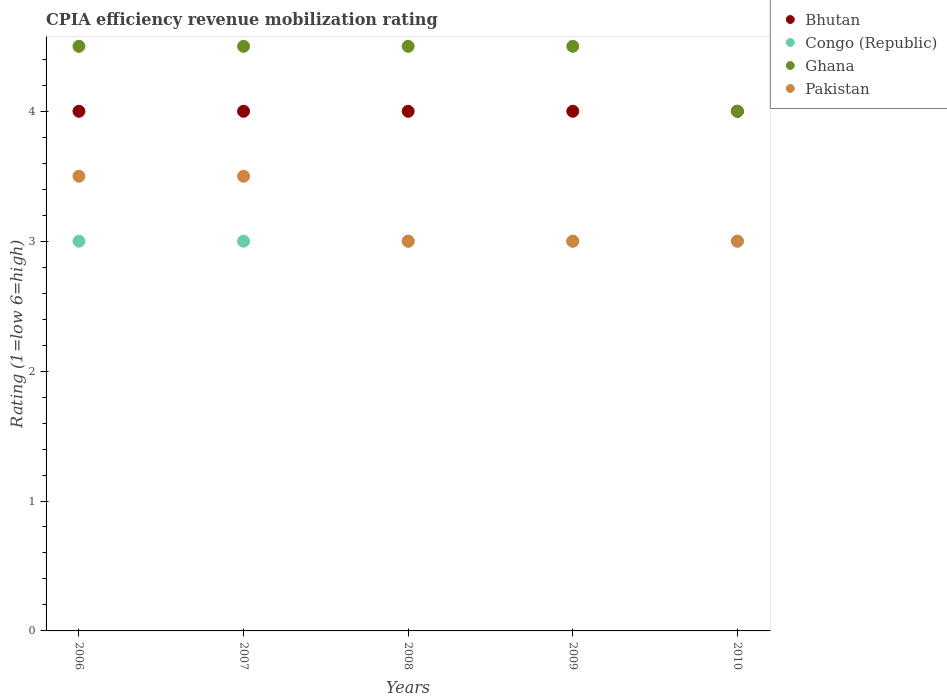Is the number of dotlines equal to the number of legend labels?
Keep it short and to the point. Yes. What is the CPIA rating in Ghana in 2008?
Offer a terse response. 4.5. Across all years, what is the maximum CPIA rating in Congo (Republic)?
Give a very brief answer. 3. Across all years, what is the minimum CPIA rating in Bhutan?
Provide a short and direct response. 4. In which year was the CPIA rating in Pakistan maximum?
Your answer should be compact. 2006. In which year was the CPIA rating in Ghana minimum?
Make the answer very short. 2010. What is the total CPIA rating in Bhutan in the graph?
Make the answer very short. 20. What is the difference between the CPIA rating in Pakistan in 2006 and that in 2008?
Your answer should be compact. 0.5. What is the difference between the CPIA rating in Congo (Republic) in 2006 and the CPIA rating in Bhutan in 2007?
Offer a terse response. -1. In the year 2007, what is the difference between the CPIA rating in Pakistan and CPIA rating in Ghana?
Offer a terse response. -1. What is the ratio of the CPIA rating in Congo (Republic) in 2006 to that in 2009?
Your response must be concise. 1. Is the CPIA rating in Congo (Republic) in 2006 less than that in 2009?
Your response must be concise. No. What is the difference between the highest and the second highest CPIA rating in Pakistan?
Your answer should be compact. 0. In how many years, is the CPIA rating in Pakistan greater than the average CPIA rating in Pakistan taken over all years?
Your response must be concise. 2. Is the sum of the CPIA rating in Congo (Republic) in 2006 and 2009 greater than the maximum CPIA rating in Bhutan across all years?
Keep it short and to the point. Yes. How many dotlines are there?
Offer a terse response. 4. What is the difference between two consecutive major ticks on the Y-axis?
Make the answer very short. 1. Are the values on the major ticks of Y-axis written in scientific E-notation?
Keep it short and to the point. No. Does the graph contain any zero values?
Your answer should be compact. No. What is the title of the graph?
Provide a succinct answer. CPIA efficiency revenue mobilization rating. What is the label or title of the Y-axis?
Keep it short and to the point. Rating (1=low 6=high). What is the Rating (1=low 6=high) in Congo (Republic) in 2006?
Offer a terse response. 3. What is the Rating (1=low 6=high) of Ghana in 2006?
Offer a very short reply. 4.5. What is the Rating (1=low 6=high) of Congo (Republic) in 2007?
Offer a very short reply. 3. What is the Rating (1=low 6=high) of Pakistan in 2007?
Provide a short and direct response. 3.5. What is the Rating (1=low 6=high) of Bhutan in 2008?
Keep it short and to the point. 4. What is the Rating (1=low 6=high) in Bhutan in 2009?
Provide a short and direct response. 4. What is the Rating (1=low 6=high) in Congo (Republic) in 2010?
Provide a short and direct response. 3. Across all years, what is the maximum Rating (1=low 6=high) in Ghana?
Your answer should be very brief. 4.5. Across all years, what is the minimum Rating (1=low 6=high) of Congo (Republic)?
Your response must be concise. 3. What is the total Rating (1=low 6=high) in Bhutan in the graph?
Your response must be concise. 20. What is the total Rating (1=low 6=high) in Congo (Republic) in the graph?
Keep it short and to the point. 15. What is the total Rating (1=low 6=high) of Pakistan in the graph?
Provide a succinct answer. 16. What is the difference between the Rating (1=low 6=high) in Bhutan in 2006 and that in 2007?
Make the answer very short. 0. What is the difference between the Rating (1=low 6=high) of Congo (Republic) in 2006 and that in 2007?
Your answer should be compact. 0. What is the difference between the Rating (1=low 6=high) of Bhutan in 2006 and that in 2008?
Offer a terse response. 0. What is the difference between the Rating (1=low 6=high) of Pakistan in 2006 and that in 2008?
Give a very brief answer. 0.5. What is the difference between the Rating (1=low 6=high) of Congo (Republic) in 2006 and that in 2009?
Offer a very short reply. 0. What is the difference between the Rating (1=low 6=high) of Ghana in 2006 and that in 2009?
Your answer should be very brief. 0. What is the difference between the Rating (1=low 6=high) in Pakistan in 2006 and that in 2009?
Your response must be concise. 0.5. What is the difference between the Rating (1=low 6=high) in Ghana in 2006 and that in 2010?
Offer a terse response. 0.5. What is the difference between the Rating (1=low 6=high) of Pakistan in 2006 and that in 2010?
Your answer should be very brief. 0.5. What is the difference between the Rating (1=low 6=high) of Congo (Republic) in 2007 and that in 2008?
Keep it short and to the point. 0. What is the difference between the Rating (1=low 6=high) in Pakistan in 2007 and that in 2008?
Make the answer very short. 0.5. What is the difference between the Rating (1=low 6=high) in Congo (Republic) in 2007 and that in 2009?
Your response must be concise. 0. What is the difference between the Rating (1=low 6=high) of Congo (Republic) in 2007 and that in 2010?
Your response must be concise. 0. What is the difference between the Rating (1=low 6=high) in Pakistan in 2008 and that in 2009?
Offer a terse response. 0. What is the difference between the Rating (1=low 6=high) in Bhutan in 2008 and that in 2010?
Offer a terse response. 0. What is the difference between the Rating (1=low 6=high) of Congo (Republic) in 2008 and that in 2010?
Offer a very short reply. 0. What is the difference between the Rating (1=low 6=high) of Ghana in 2008 and that in 2010?
Provide a succinct answer. 0.5. What is the difference between the Rating (1=low 6=high) of Pakistan in 2008 and that in 2010?
Make the answer very short. 0. What is the difference between the Rating (1=low 6=high) in Bhutan in 2009 and that in 2010?
Your response must be concise. 0. What is the difference between the Rating (1=low 6=high) of Pakistan in 2009 and that in 2010?
Ensure brevity in your answer.  0. What is the difference between the Rating (1=low 6=high) of Bhutan in 2006 and the Rating (1=low 6=high) of Congo (Republic) in 2007?
Your answer should be very brief. 1. What is the difference between the Rating (1=low 6=high) in Bhutan in 2006 and the Rating (1=low 6=high) in Ghana in 2007?
Make the answer very short. -0.5. What is the difference between the Rating (1=low 6=high) of Congo (Republic) in 2006 and the Rating (1=low 6=high) of Ghana in 2007?
Provide a short and direct response. -1.5. What is the difference between the Rating (1=low 6=high) of Ghana in 2006 and the Rating (1=low 6=high) of Pakistan in 2007?
Your answer should be very brief. 1. What is the difference between the Rating (1=low 6=high) of Bhutan in 2006 and the Rating (1=low 6=high) of Pakistan in 2008?
Keep it short and to the point. 1. What is the difference between the Rating (1=low 6=high) in Congo (Republic) in 2006 and the Rating (1=low 6=high) in Pakistan in 2008?
Keep it short and to the point. 0. What is the difference between the Rating (1=low 6=high) of Ghana in 2006 and the Rating (1=low 6=high) of Pakistan in 2008?
Your response must be concise. 1.5. What is the difference between the Rating (1=low 6=high) of Bhutan in 2006 and the Rating (1=low 6=high) of Congo (Republic) in 2009?
Provide a succinct answer. 1. What is the difference between the Rating (1=low 6=high) in Bhutan in 2006 and the Rating (1=low 6=high) in Ghana in 2009?
Provide a short and direct response. -0.5. What is the difference between the Rating (1=low 6=high) of Ghana in 2006 and the Rating (1=low 6=high) of Pakistan in 2009?
Make the answer very short. 1.5. What is the difference between the Rating (1=low 6=high) of Bhutan in 2006 and the Rating (1=low 6=high) of Ghana in 2010?
Your answer should be compact. 0. What is the difference between the Rating (1=low 6=high) of Congo (Republic) in 2006 and the Rating (1=low 6=high) of Ghana in 2010?
Offer a terse response. -1. What is the difference between the Rating (1=low 6=high) in Ghana in 2006 and the Rating (1=low 6=high) in Pakistan in 2010?
Ensure brevity in your answer.  1.5. What is the difference between the Rating (1=low 6=high) in Congo (Republic) in 2007 and the Rating (1=low 6=high) in Pakistan in 2008?
Offer a very short reply. 0. What is the difference between the Rating (1=low 6=high) in Ghana in 2007 and the Rating (1=low 6=high) in Pakistan in 2008?
Offer a very short reply. 1.5. What is the difference between the Rating (1=low 6=high) of Bhutan in 2007 and the Rating (1=low 6=high) of Congo (Republic) in 2009?
Your response must be concise. 1. What is the difference between the Rating (1=low 6=high) in Bhutan in 2007 and the Rating (1=low 6=high) in Ghana in 2009?
Ensure brevity in your answer.  -0.5. What is the difference between the Rating (1=low 6=high) in Bhutan in 2007 and the Rating (1=low 6=high) in Pakistan in 2009?
Provide a short and direct response. 1. What is the difference between the Rating (1=low 6=high) in Congo (Republic) in 2007 and the Rating (1=low 6=high) in Pakistan in 2009?
Provide a succinct answer. 0. What is the difference between the Rating (1=low 6=high) in Ghana in 2007 and the Rating (1=low 6=high) in Pakistan in 2009?
Your answer should be compact. 1.5. What is the difference between the Rating (1=low 6=high) of Bhutan in 2007 and the Rating (1=low 6=high) of Ghana in 2010?
Your response must be concise. 0. What is the difference between the Rating (1=low 6=high) in Bhutan in 2007 and the Rating (1=low 6=high) in Pakistan in 2010?
Provide a succinct answer. 1. What is the difference between the Rating (1=low 6=high) in Congo (Republic) in 2007 and the Rating (1=low 6=high) in Ghana in 2010?
Ensure brevity in your answer.  -1. What is the difference between the Rating (1=low 6=high) in Ghana in 2007 and the Rating (1=low 6=high) in Pakistan in 2010?
Make the answer very short. 1.5. What is the difference between the Rating (1=low 6=high) in Bhutan in 2008 and the Rating (1=low 6=high) in Congo (Republic) in 2009?
Make the answer very short. 1. What is the difference between the Rating (1=low 6=high) of Bhutan in 2008 and the Rating (1=low 6=high) of Pakistan in 2009?
Your answer should be compact. 1. What is the difference between the Rating (1=low 6=high) in Congo (Republic) in 2008 and the Rating (1=low 6=high) in Ghana in 2009?
Offer a very short reply. -1.5. What is the difference between the Rating (1=low 6=high) in Ghana in 2008 and the Rating (1=low 6=high) in Pakistan in 2009?
Keep it short and to the point. 1.5. What is the difference between the Rating (1=low 6=high) in Congo (Republic) in 2008 and the Rating (1=low 6=high) in Ghana in 2010?
Make the answer very short. -1. What is the difference between the Rating (1=low 6=high) of Congo (Republic) in 2008 and the Rating (1=low 6=high) of Pakistan in 2010?
Provide a short and direct response. 0. What is the difference between the Rating (1=low 6=high) in Ghana in 2008 and the Rating (1=low 6=high) in Pakistan in 2010?
Ensure brevity in your answer.  1.5. What is the difference between the Rating (1=low 6=high) in Bhutan in 2009 and the Rating (1=low 6=high) in Congo (Republic) in 2010?
Your answer should be very brief. 1. What is the difference between the Rating (1=low 6=high) of Bhutan in 2009 and the Rating (1=low 6=high) of Ghana in 2010?
Make the answer very short. 0. What is the difference between the Rating (1=low 6=high) of Bhutan in 2009 and the Rating (1=low 6=high) of Pakistan in 2010?
Your answer should be very brief. 1. What is the difference between the Rating (1=low 6=high) of Congo (Republic) in 2009 and the Rating (1=low 6=high) of Ghana in 2010?
Give a very brief answer. -1. What is the difference between the Rating (1=low 6=high) in Congo (Republic) in 2009 and the Rating (1=low 6=high) in Pakistan in 2010?
Provide a succinct answer. 0. What is the average Rating (1=low 6=high) of Ghana per year?
Offer a terse response. 4.4. In the year 2006, what is the difference between the Rating (1=low 6=high) in Bhutan and Rating (1=low 6=high) in Congo (Republic)?
Keep it short and to the point. 1. In the year 2006, what is the difference between the Rating (1=low 6=high) in Congo (Republic) and Rating (1=low 6=high) in Ghana?
Your answer should be compact. -1.5. In the year 2007, what is the difference between the Rating (1=low 6=high) in Bhutan and Rating (1=low 6=high) in Pakistan?
Provide a short and direct response. 0.5. In the year 2007, what is the difference between the Rating (1=low 6=high) of Congo (Republic) and Rating (1=low 6=high) of Ghana?
Offer a very short reply. -1.5. In the year 2007, what is the difference between the Rating (1=low 6=high) of Ghana and Rating (1=low 6=high) of Pakistan?
Offer a terse response. 1. In the year 2008, what is the difference between the Rating (1=low 6=high) of Bhutan and Rating (1=low 6=high) of Congo (Republic)?
Ensure brevity in your answer.  1. In the year 2008, what is the difference between the Rating (1=low 6=high) in Bhutan and Rating (1=low 6=high) in Ghana?
Your answer should be compact. -0.5. In the year 2008, what is the difference between the Rating (1=low 6=high) of Congo (Republic) and Rating (1=low 6=high) of Pakistan?
Make the answer very short. 0. In the year 2008, what is the difference between the Rating (1=low 6=high) in Ghana and Rating (1=low 6=high) in Pakistan?
Give a very brief answer. 1.5. In the year 2009, what is the difference between the Rating (1=low 6=high) in Bhutan and Rating (1=low 6=high) in Pakistan?
Provide a short and direct response. 1. In the year 2009, what is the difference between the Rating (1=low 6=high) in Ghana and Rating (1=low 6=high) in Pakistan?
Offer a very short reply. 1.5. In the year 2010, what is the difference between the Rating (1=low 6=high) in Bhutan and Rating (1=low 6=high) in Congo (Republic)?
Keep it short and to the point. 1. In the year 2010, what is the difference between the Rating (1=low 6=high) in Bhutan and Rating (1=low 6=high) in Pakistan?
Provide a succinct answer. 1. What is the ratio of the Rating (1=low 6=high) of Bhutan in 2006 to that in 2007?
Give a very brief answer. 1. What is the ratio of the Rating (1=low 6=high) in Congo (Republic) in 2006 to that in 2007?
Keep it short and to the point. 1. What is the ratio of the Rating (1=low 6=high) in Pakistan in 2006 to that in 2007?
Offer a terse response. 1. What is the ratio of the Rating (1=low 6=high) in Bhutan in 2006 to that in 2008?
Ensure brevity in your answer.  1. What is the ratio of the Rating (1=low 6=high) of Ghana in 2006 to that in 2008?
Give a very brief answer. 1. What is the ratio of the Rating (1=low 6=high) in Pakistan in 2006 to that in 2009?
Your response must be concise. 1.17. What is the ratio of the Rating (1=low 6=high) in Pakistan in 2006 to that in 2010?
Provide a short and direct response. 1.17. What is the ratio of the Rating (1=low 6=high) of Congo (Republic) in 2007 to that in 2008?
Ensure brevity in your answer.  1. What is the ratio of the Rating (1=low 6=high) of Pakistan in 2007 to that in 2008?
Make the answer very short. 1.17. What is the ratio of the Rating (1=low 6=high) of Congo (Republic) in 2008 to that in 2009?
Ensure brevity in your answer.  1. What is the ratio of the Rating (1=low 6=high) of Pakistan in 2008 to that in 2009?
Keep it short and to the point. 1. What is the ratio of the Rating (1=low 6=high) in Bhutan in 2008 to that in 2010?
Ensure brevity in your answer.  1. What is the ratio of the Rating (1=low 6=high) of Ghana in 2008 to that in 2010?
Provide a succinct answer. 1.12. What is the ratio of the Rating (1=low 6=high) of Bhutan in 2009 to that in 2010?
Offer a very short reply. 1. What is the ratio of the Rating (1=low 6=high) in Ghana in 2009 to that in 2010?
Offer a terse response. 1.12. What is the difference between the highest and the second highest Rating (1=low 6=high) in Bhutan?
Offer a terse response. 0. What is the difference between the highest and the second highest Rating (1=low 6=high) of Congo (Republic)?
Ensure brevity in your answer.  0. What is the difference between the highest and the second highest Rating (1=low 6=high) of Ghana?
Offer a terse response. 0. What is the difference between the highest and the second highest Rating (1=low 6=high) of Pakistan?
Provide a succinct answer. 0. What is the difference between the highest and the lowest Rating (1=low 6=high) in Bhutan?
Your answer should be compact. 0. What is the difference between the highest and the lowest Rating (1=low 6=high) in Ghana?
Your answer should be compact. 0.5. 